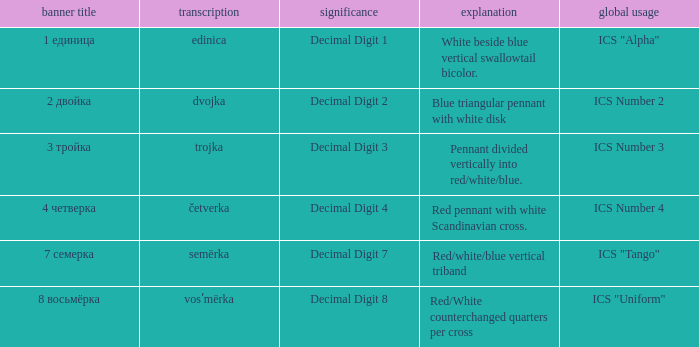What is the international use of the 1 единица flag? ICS "Alpha". 